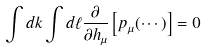<formula> <loc_0><loc_0><loc_500><loc_500>\int d k \int d \ell \frac { \partial } { \partial h _ { \mu } } \left [ p _ { \mu } ( \cdots ) \right ] = 0</formula> 